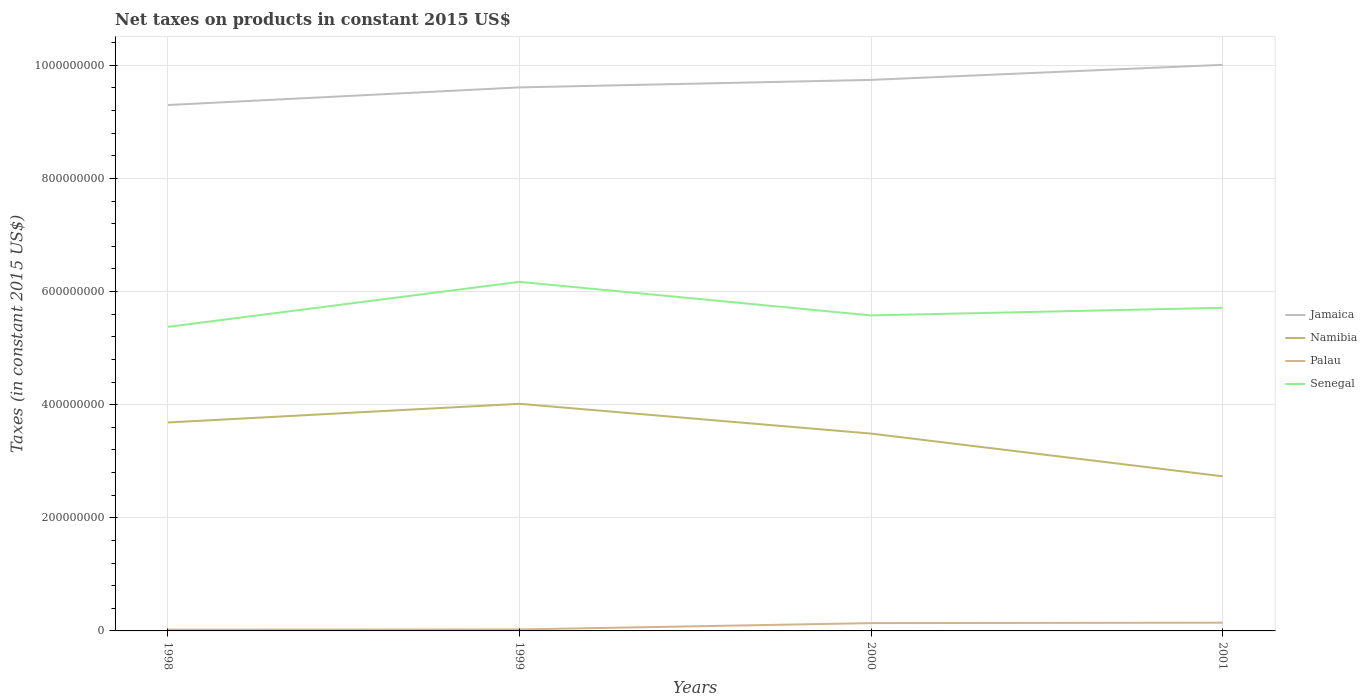How many different coloured lines are there?
Your answer should be compact. 4. Does the line corresponding to Namibia intersect with the line corresponding to Senegal?
Give a very brief answer. No. Across all years, what is the maximum net taxes on products in Namibia?
Give a very brief answer. 2.73e+08. In which year was the net taxes on products in Jamaica maximum?
Give a very brief answer. 1998. What is the total net taxes on products in Jamaica in the graph?
Your response must be concise. -3.12e+07. What is the difference between the highest and the second highest net taxes on products in Senegal?
Keep it short and to the point. 7.96e+07. What is the difference between the highest and the lowest net taxes on products in Namibia?
Provide a short and direct response. 3. How many legend labels are there?
Offer a very short reply. 4. What is the title of the graph?
Give a very brief answer. Net taxes on products in constant 2015 US$. What is the label or title of the X-axis?
Your answer should be very brief. Years. What is the label or title of the Y-axis?
Your response must be concise. Taxes (in constant 2015 US$). What is the Taxes (in constant 2015 US$) in Jamaica in 1998?
Your answer should be compact. 9.30e+08. What is the Taxes (in constant 2015 US$) in Namibia in 1998?
Make the answer very short. 3.69e+08. What is the Taxes (in constant 2015 US$) in Palau in 1998?
Your response must be concise. 2.23e+06. What is the Taxes (in constant 2015 US$) of Senegal in 1998?
Make the answer very short. 5.38e+08. What is the Taxes (in constant 2015 US$) in Jamaica in 1999?
Your response must be concise. 9.61e+08. What is the Taxes (in constant 2015 US$) in Namibia in 1999?
Provide a short and direct response. 4.02e+08. What is the Taxes (in constant 2015 US$) of Palau in 1999?
Ensure brevity in your answer.  2.59e+06. What is the Taxes (in constant 2015 US$) of Senegal in 1999?
Ensure brevity in your answer.  6.17e+08. What is the Taxes (in constant 2015 US$) of Jamaica in 2000?
Ensure brevity in your answer.  9.74e+08. What is the Taxes (in constant 2015 US$) in Namibia in 2000?
Keep it short and to the point. 3.49e+08. What is the Taxes (in constant 2015 US$) in Palau in 2000?
Ensure brevity in your answer.  1.38e+07. What is the Taxes (in constant 2015 US$) of Senegal in 2000?
Make the answer very short. 5.58e+08. What is the Taxes (in constant 2015 US$) of Jamaica in 2001?
Ensure brevity in your answer.  1.00e+09. What is the Taxes (in constant 2015 US$) in Namibia in 2001?
Your answer should be compact. 2.73e+08. What is the Taxes (in constant 2015 US$) in Palau in 2001?
Offer a very short reply. 1.46e+07. What is the Taxes (in constant 2015 US$) in Senegal in 2001?
Make the answer very short. 5.71e+08. Across all years, what is the maximum Taxes (in constant 2015 US$) of Jamaica?
Make the answer very short. 1.00e+09. Across all years, what is the maximum Taxes (in constant 2015 US$) of Namibia?
Provide a succinct answer. 4.02e+08. Across all years, what is the maximum Taxes (in constant 2015 US$) in Palau?
Your answer should be compact. 1.46e+07. Across all years, what is the maximum Taxes (in constant 2015 US$) in Senegal?
Provide a short and direct response. 6.17e+08. Across all years, what is the minimum Taxes (in constant 2015 US$) in Jamaica?
Your response must be concise. 9.30e+08. Across all years, what is the minimum Taxes (in constant 2015 US$) of Namibia?
Your answer should be compact. 2.73e+08. Across all years, what is the minimum Taxes (in constant 2015 US$) of Palau?
Your answer should be compact. 2.23e+06. Across all years, what is the minimum Taxes (in constant 2015 US$) of Senegal?
Offer a very short reply. 5.38e+08. What is the total Taxes (in constant 2015 US$) of Jamaica in the graph?
Ensure brevity in your answer.  3.87e+09. What is the total Taxes (in constant 2015 US$) of Namibia in the graph?
Give a very brief answer. 1.39e+09. What is the total Taxes (in constant 2015 US$) of Palau in the graph?
Provide a short and direct response. 3.32e+07. What is the total Taxes (in constant 2015 US$) of Senegal in the graph?
Provide a succinct answer. 2.28e+09. What is the difference between the Taxes (in constant 2015 US$) of Jamaica in 1998 and that in 1999?
Offer a terse response. -3.12e+07. What is the difference between the Taxes (in constant 2015 US$) in Namibia in 1998 and that in 1999?
Keep it short and to the point. -3.30e+07. What is the difference between the Taxes (in constant 2015 US$) of Palau in 1998 and that in 1999?
Provide a succinct answer. -3.59e+05. What is the difference between the Taxes (in constant 2015 US$) in Senegal in 1998 and that in 1999?
Offer a terse response. -7.96e+07. What is the difference between the Taxes (in constant 2015 US$) of Jamaica in 1998 and that in 2000?
Offer a very short reply. -4.44e+07. What is the difference between the Taxes (in constant 2015 US$) of Namibia in 1998 and that in 2000?
Offer a very short reply. 1.97e+07. What is the difference between the Taxes (in constant 2015 US$) in Palau in 1998 and that in 2000?
Your response must be concise. -1.16e+07. What is the difference between the Taxes (in constant 2015 US$) in Senegal in 1998 and that in 2000?
Ensure brevity in your answer.  -2.02e+07. What is the difference between the Taxes (in constant 2015 US$) in Jamaica in 1998 and that in 2001?
Provide a short and direct response. -7.11e+07. What is the difference between the Taxes (in constant 2015 US$) in Namibia in 1998 and that in 2001?
Your answer should be compact. 9.52e+07. What is the difference between the Taxes (in constant 2015 US$) in Palau in 1998 and that in 2001?
Make the answer very short. -1.23e+07. What is the difference between the Taxes (in constant 2015 US$) in Senegal in 1998 and that in 2001?
Your answer should be compact. -3.37e+07. What is the difference between the Taxes (in constant 2015 US$) of Jamaica in 1999 and that in 2000?
Offer a very short reply. -1.32e+07. What is the difference between the Taxes (in constant 2015 US$) of Namibia in 1999 and that in 2000?
Your answer should be very brief. 5.26e+07. What is the difference between the Taxes (in constant 2015 US$) in Palau in 1999 and that in 2000?
Your answer should be very brief. -1.12e+07. What is the difference between the Taxes (in constant 2015 US$) in Senegal in 1999 and that in 2000?
Your answer should be compact. 5.94e+07. What is the difference between the Taxes (in constant 2015 US$) of Jamaica in 1999 and that in 2001?
Make the answer very short. -3.99e+07. What is the difference between the Taxes (in constant 2015 US$) of Namibia in 1999 and that in 2001?
Keep it short and to the point. 1.28e+08. What is the difference between the Taxes (in constant 2015 US$) in Palau in 1999 and that in 2001?
Offer a terse response. -1.20e+07. What is the difference between the Taxes (in constant 2015 US$) of Senegal in 1999 and that in 2001?
Offer a terse response. 4.59e+07. What is the difference between the Taxes (in constant 2015 US$) of Jamaica in 2000 and that in 2001?
Keep it short and to the point. -2.67e+07. What is the difference between the Taxes (in constant 2015 US$) in Namibia in 2000 and that in 2001?
Make the answer very short. 7.55e+07. What is the difference between the Taxes (in constant 2015 US$) of Palau in 2000 and that in 2001?
Ensure brevity in your answer.  -7.40e+05. What is the difference between the Taxes (in constant 2015 US$) of Senegal in 2000 and that in 2001?
Offer a very short reply. -1.35e+07. What is the difference between the Taxes (in constant 2015 US$) of Jamaica in 1998 and the Taxes (in constant 2015 US$) of Namibia in 1999?
Your answer should be very brief. 5.28e+08. What is the difference between the Taxes (in constant 2015 US$) in Jamaica in 1998 and the Taxes (in constant 2015 US$) in Palau in 1999?
Your response must be concise. 9.27e+08. What is the difference between the Taxes (in constant 2015 US$) in Jamaica in 1998 and the Taxes (in constant 2015 US$) in Senegal in 1999?
Give a very brief answer. 3.13e+08. What is the difference between the Taxes (in constant 2015 US$) in Namibia in 1998 and the Taxes (in constant 2015 US$) in Palau in 1999?
Provide a short and direct response. 3.66e+08. What is the difference between the Taxes (in constant 2015 US$) in Namibia in 1998 and the Taxes (in constant 2015 US$) in Senegal in 1999?
Your answer should be very brief. -2.49e+08. What is the difference between the Taxes (in constant 2015 US$) of Palau in 1998 and the Taxes (in constant 2015 US$) of Senegal in 1999?
Your answer should be very brief. -6.15e+08. What is the difference between the Taxes (in constant 2015 US$) of Jamaica in 1998 and the Taxes (in constant 2015 US$) of Namibia in 2000?
Offer a terse response. 5.81e+08. What is the difference between the Taxes (in constant 2015 US$) in Jamaica in 1998 and the Taxes (in constant 2015 US$) in Palau in 2000?
Your answer should be very brief. 9.16e+08. What is the difference between the Taxes (in constant 2015 US$) of Jamaica in 1998 and the Taxes (in constant 2015 US$) of Senegal in 2000?
Your response must be concise. 3.72e+08. What is the difference between the Taxes (in constant 2015 US$) in Namibia in 1998 and the Taxes (in constant 2015 US$) in Palau in 2000?
Ensure brevity in your answer.  3.55e+08. What is the difference between the Taxes (in constant 2015 US$) of Namibia in 1998 and the Taxes (in constant 2015 US$) of Senegal in 2000?
Give a very brief answer. -1.89e+08. What is the difference between the Taxes (in constant 2015 US$) of Palau in 1998 and the Taxes (in constant 2015 US$) of Senegal in 2000?
Keep it short and to the point. -5.56e+08. What is the difference between the Taxes (in constant 2015 US$) of Jamaica in 1998 and the Taxes (in constant 2015 US$) of Namibia in 2001?
Provide a succinct answer. 6.56e+08. What is the difference between the Taxes (in constant 2015 US$) in Jamaica in 1998 and the Taxes (in constant 2015 US$) in Palau in 2001?
Offer a terse response. 9.15e+08. What is the difference between the Taxes (in constant 2015 US$) in Jamaica in 1998 and the Taxes (in constant 2015 US$) in Senegal in 2001?
Keep it short and to the point. 3.58e+08. What is the difference between the Taxes (in constant 2015 US$) in Namibia in 1998 and the Taxes (in constant 2015 US$) in Palau in 2001?
Make the answer very short. 3.54e+08. What is the difference between the Taxes (in constant 2015 US$) of Namibia in 1998 and the Taxes (in constant 2015 US$) of Senegal in 2001?
Provide a short and direct response. -2.03e+08. What is the difference between the Taxes (in constant 2015 US$) in Palau in 1998 and the Taxes (in constant 2015 US$) in Senegal in 2001?
Your answer should be very brief. -5.69e+08. What is the difference between the Taxes (in constant 2015 US$) of Jamaica in 1999 and the Taxes (in constant 2015 US$) of Namibia in 2000?
Provide a short and direct response. 6.12e+08. What is the difference between the Taxes (in constant 2015 US$) of Jamaica in 1999 and the Taxes (in constant 2015 US$) of Palau in 2000?
Keep it short and to the point. 9.47e+08. What is the difference between the Taxes (in constant 2015 US$) of Jamaica in 1999 and the Taxes (in constant 2015 US$) of Senegal in 2000?
Your answer should be compact. 4.03e+08. What is the difference between the Taxes (in constant 2015 US$) of Namibia in 1999 and the Taxes (in constant 2015 US$) of Palau in 2000?
Your answer should be compact. 3.88e+08. What is the difference between the Taxes (in constant 2015 US$) in Namibia in 1999 and the Taxes (in constant 2015 US$) in Senegal in 2000?
Give a very brief answer. -1.56e+08. What is the difference between the Taxes (in constant 2015 US$) in Palau in 1999 and the Taxes (in constant 2015 US$) in Senegal in 2000?
Offer a terse response. -5.55e+08. What is the difference between the Taxes (in constant 2015 US$) in Jamaica in 1999 and the Taxes (in constant 2015 US$) in Namibia in 2001?
Your answer should be very brief. 6.88e+08. What is the difference between the Taxes (in constant 2015 US$) in Jamaica in 1999 and the Taxes (in constant 2015 US$) in Palau in 2001?
Make the answer very short. 9.46e+08. What is the difference between the Taxes (in constant 2015 US$) in Jamaica in 1999 and the Taxes (in constant 2015 US$) in Senegal in 2001?
Offer a terse response. 3.90e+08. What is the difference between the Taxes (in constant 2015 US$) in Namibia in 1999 and the Taxes (in constant 2015 US$) in Palau in 2001?
Offer a terse response. 3.87e+08. What is the difference between the Taxes (in constant 2015 US$) in Namibia in 1999 and the Taxes (in constant 2015 US$) in Senegal in 2001?
Your response must be concise. -1.70e+08. What is the difference between the Taxes (in constant 2015 US$) of Palau in 1999 and the Taxes (in constant 2015 US$) of Senegal in 2001?
Keep it short and to the point. -5.69e+08. What is the difference between the Taxes (in constant 2015 US$) of Jamaica in 2000 and the Taxes (in constant 2015 US$) of Namibia in 2001?
Your answer should be compact. 7.01e+08. What is the difference between the Taxes (in constant 2015 US$) of Jamaica in 2000 and the Taxes (in constant 2015 US$) of Palau in 2001?
Keep it short and to the point. 9.60e+08. What is the difference between the Taxes (in constant 2015 US$) in Jamaica in 2000 and the Taxes (in constant 2015 US$) in Senegal in 2001?
Offer a terse response. 4.03e+08. What is the difference between the Taxes (in constant 2015 US$) of Namibia in 2000 and the Taxes (in constant 2015 US$) of Palau in 2001?
Keep it short and to the point. 3.34e+08. What is the difference between the Taxes (in constant 2015 US$) of Namibia in 2000 and the Taxes (in constant 2015 US$) of Senegal in 2001?
Your answer should be very brief. -2.22e+08. What is the difference between the Taxes (in constant 2015 US$) in Palau in 2000 and the Taxes (in constant 2015 US$) in Senegal in 2001?
Your answer should be compact. -5.57e+08. What is the average Taxes (in constant 2015 US$) of Jamaica per year?
Keep it short and to the point. 9.66e+08. What is the average Taxes (in constant 2015 US$) of Namibia per year?
Offer a very short reply. 3.48e+08. What is the average Taxes (in constant 2015 US$) of Palau per year?
Provide a short and direct response. 8.29e+06. What is the average Taxes (in constant 2015 US$) of Senegal per year?
Give a very brief answer. 5.71e+08. In the year 1998, what is the difference between the Taxes (in constant 2015 US$) of Jamaica and Taxes (in constant 2015 US$) of Namibia?
Provide a succinct answer. 5.61e+08. In the year 1998, what is the difference between the Taxes (in constant 2015 US$) in Jamaica and Taxes (in constant 2015 US$) in Palau?
Your answer should be compact. 9.27e+08. In the year 1998, what is the difference between the Taxes (in constant 2015 US$) in Jamaica and Taxes (in constant 2015 US$) in Senegal?
Give a very brief answer. 3.92e+08. In the year 1998, what is the difference between the Taxes (in constant 2015 US$) of Namibia and Taxes (in constant 2015 US$) of Palau?
Provide a succinct answer. 3.66e+08. In the year 1998, what is the difference between the Taxes (in constant 2015 US$) of Namibia and Taxes (in constant 2015 US$) of Senegal?
Keep it short and to the point. -1.69e+08. In the year 1998, what is the difference between the Taxes (in constant 2015 US$) in Palau and Taxes (in constant 2015 US$) in Senegal?
Your answer should be very brief. -5.35e+08. In the year 1999, what is the difference between the Taxes (in constant 2015 US$) of Jamaica and Taxes (in constant 2015 US$) of Namibia?
Your answer should be compact. 5.59e+08. In the year 1999, what is the difference between the Taxes (in constant 2015 US$) of Jamaica and Taxes (in constant 2015 US$) of Palau?
Give a very brief answer. 9.58e+08. In the year 1999, what is the difference between the Taxes (in constant 2015 US$) of Jamaica and Taxes (in constant 2015 US$) of Senegal?
Your answer should be very brief. 3.44e+08. In the year 1999, what is the difference between the Taxes (in constant 2015 US$) in Namibia and Taxes (in constant 2015 US$) in Palau?
Offer a very short reply. 3.99e+08. In the year 1999, what is the difference between the Taxes (in constant 2015 US$) of Namibia and Taxes (in constant 2015 US$) of Senegal?
Your answer should be very brief. -2.16e+08. In the year 1999, what is the difference between the Taxes (in constant 2015 US$) in Palau and Taxes (in constant 2015 US$) in Senegal?
Provide a succinct answer. -6.15e+08. In the year 2000, what is the difference between the Taxes (in constant 2015 US$) in Jamaica and Taxes (in constant 2015 US$) in Namibia?
Provide a short and direct response. 6.25e+08. In the year 2000, what is the difference between the Taxes (in constant 2015 US$) in Jamaica and Taxes (in constant 2015 US$) in Palau?
Keep it short and to the point. 9.60e+08. In the year 2000, what is the difference between the Taxes (in constant 2015 US$) in Jamaica and Taxes (in constant 2015 US$) in Senegal?
Your response must be concise. 4.16e+08. In the year 2000, what is the difference between the Taxes (in constant 2015 US$) in Namibia and Taxes (in constant 2015 US$) in Palau?
Your answer should be compact. 3.35e+08. In the year 2000, what is the difference between the Taxes (in constant 2015 US$) in Namibia and Taxes (in constant 2015 US$) in Senegal?
Your response must be concise. -2.09e+08. In the year 2000, what is the difference between the Taxes (in constant 2015 US$) in Palau and Taxes (in constant 2015 US$) in Senegal?
Offer a terse response. -5.44e+08. In the year 2001, what is the difference between the Taxes (in constant 2015 US$) of Jamaica and Taxes (in constant 2015 US$) of Namibia?
Ensure brevity in your answer.  7.27e+08. In the year 2001, what is the difference between the Taxes (in constant 2015 US$) in Jamaica and Taxes (in constant 2015 US$) in Palau?
Your answer should be compact. 9.86e+08. In the year 2001, what is the difference between the Taxes (in constant 2015 US$) of Jamaica and Taxes (in constant 2015 US$) of Senegal?
Make the answer very short. 4.30e+08. In the year 2001, what is the difference between the Taxes (in constant 2015 US$) of Namibia and Taxes (in constant 2015 US$) of Palau?
Your answer should be compact. 2.59e+08. In the year 2001, what is the difference between the Taxes (in constant 2015 US$) of Namibia and Taxes (in constant 2015 US$) of Senegal?
Your answer should be compact. -2.98e+08. In the year 2001, what is the difference between the Taxes (in constant 2015 US$) of Palau and Taxes (in constant 2015 US$) of Senegal?
Keep it short and to the point. -5.57e+08. What is the ratio of the Taxes (in constant 2015 US$) of Jamaica in 1998 to that in 1999?
Provide a succinct answer. 0.97. What is the ratio of the Taxes (in constant 2015 US$) of Namibia in 1998 to that in 1999?
Make the answer very short. 0.92. What is the ratio of the Taxes (in constant 2015 US$) in Palau in 1998 to that in 1999?
Your response must be concise. 0.86. What is the ratio of the Taxes (in constant 2015 US$) of Senegal in 1998 to that in 1999?
Ensure brevity in your answer.  0.87. What is the ratio of the Taxes (in constant 2015 US$) in Jamaica in 1998 to that in 2000?
Your answer should be compact. 0.95. What is the ratio of the Taxes (in constant 2015 US$) of Namibia in 1998 to that in 2000?
Offer a very short reply. 1.06. What is the ratio of the Taxes (in constant 2015 US$) in Palau in 1998 to that in 2000?
Ensure brevity in your answer.  0.16. What is the ratio of the Taxes (in constant 2015 US$) in Senegal in 1998 to that in 2000?
Your response must be concise. 0.96. What is the ratio of the Taxes (in constant 2015 US$) of Jamaica in 1998 to that in 2001?
Offer a very short reply. 0.93. What is the ratio of the Taxes (in constant 2015 US$) of Namibia in 1998 to that in 2001?
Your response must be concise. 1.35. What is the ratio of the Taxes (in constant 2015 US$) of Palau in 1998 to that in 2001?
Provide a short and direct response. 0.15. What is the ratio of the Taxes (in constant 2015 US$) in Senegal in 1998 to that in 2001?
Your answer should be compact. 0.94. What is the ratio of the Taxes (in constant 2015 US$) of Jamaica in 1999 to that in 2000?
Give a very brief answer. 0.99. What is the ratio of the Taxes (in constant 2015 US$) in Namibia in 1999 to that in 2000?
Your answer should be compact. 1.15. What is the ratio of the Taxes (in constant 2015 US$) in Palau in 1999 to that in 2000?
Offer a very short reply. 0.19. What is the ratio of the Taxes (in constant 2015 US$) in Senegal in 1999 to that in 2000?
Provide a short and direct response. 1.11. What is the ratio of the Taxes (in constant 2015 US$) of Jamaica in 1999 to that in 2001?
Ensure brevity in your answer.  0.96. What is the ratio of the Taxes (in constant 2015 US$) in Namibia in 1999 to that in 2001?
Give a very brief answer. 1.47. What is the ratio of the Taxes (in constant 2015 US$) of Palau in 1999 to that in 2001?
Keep it short and to the point. 0.18. What is the ratio of the Taxes (in constant 2015 US$) of Senegal in 1999 to that in 2001?
Offer a terse response. 1.08. What is the ratio of the Taxes (in constant 2015 US$) in Jamaica in 2000 to that in 2001?
Offer a terse response. 0.97. What is the ratio of the Taxes (in constant 2015 US$) in Namibia in 2000 to that in 2001?
Offer a very short reply. 1.28. What is the ratio of the Taxes (in constant 2015 US$) in Palau in 2000 to that in 2001?
Ensure brevity in your answer.  0.95. What is the ratio of the Taxes (in constant 2015 US$) of Senegal in 2000 to that in 2001?
Your answer should be compact. 0.98. What is the difference between the highest and the second highest Taxes (in constant 2015 US$) of Jamaica?
Make the answer very short. 2.67e+07. What is the difference between the highest and the second highest Taxes (in constant 2015 US$) in Namibia?
Give a very brief answer. 3.30e+07. What is the difference between the highest and the second highest Taxes (in constant 2015 US$) in Palau?
Provide a short and direct response. 7.40e+05. What is the difference between the highest and the second highest Taxes (in constant 2015 US$) of Senegal?
Keep it short and to the point. 4.59e+07. What is the difference between the highest and the lowest Taxes (in constant 2015 US$) of Jamaica?
Offer a terse response. 7.11e+07. What is the difference between the highest and the lowest Taxes (in constant 2015 US$) of Namibia?
Ensure brevity in your answer.  1.28e+08. What is the difference between the highest and the lowest Taxes (in constant 2015 US$) of Palau?
Make the answer very short. 1.23e+07. What is the difference between the highest and the lowest Taxes (in constant 2015 US$) of Senegal?
Provide a short and direct response. 7.96e+07. 